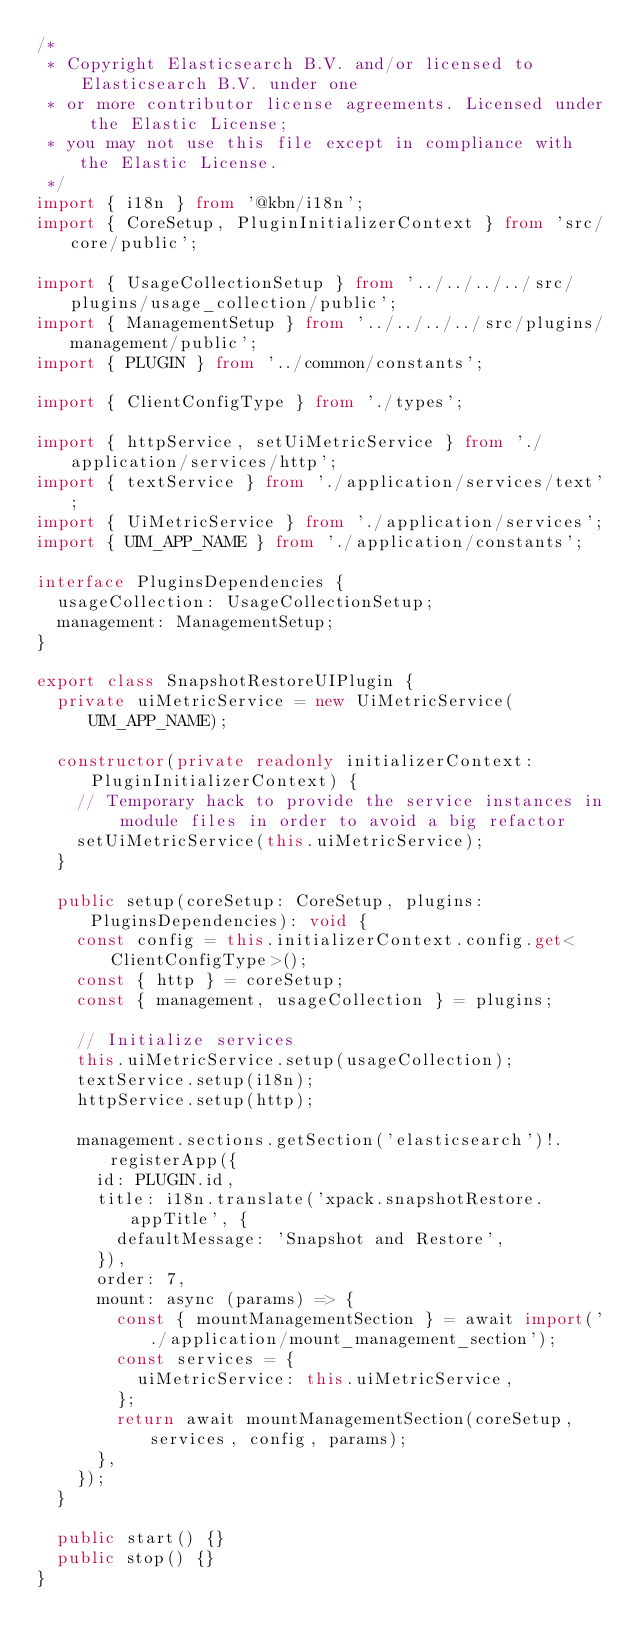Convert code to text. <code><loc_0><loc_0><loc_500><loc_500><_TypeScript_>/*
 * Copyright Elasticsearch B.V. and/or licensed to Elasticsearch B.V. under one
 * or more contributor license agreements. Licensed under the Elastic License;
 * you may not use this file except in compliance with the Elastic License.
 */
import { i18n } from '@kbn/i18n';
import { CoreSetup, PluginInitializerContext } from 'src/core/public';

import { UsageCollectionSetup } from '../../../../src/plugins/usage_collection/public';
import { ManagementSetup } from '../../../../src/plugins/management/public';
import { PLUGIN } from '../common/constants';

import { ClientConfigType } from './types';

import { httpService, setUiMetricService } from './application/services/http';
import { textService } from './application/services/text';
import { UiMetricService } from './application/services';
import { UIM_APP_NAME } from './application/constants';

interface PluginsDependencies {
  usageCollection: UsageCollectionSetup;
  management: ManagementSetup;
}

export class SnapshotRestoreUIPlugin {
  private uiMetricService = new UiMetricService(UIM_APP_NAME);

  constructor(private readonly initializerContext: PluginInitializerContext) {
    // Temporary hack to provide the service instances in module files in order to avoid a big refactor
    setUiMetricService(this.uiMetricService);
  }

  public setup(coreSetup: CoreSetup, plugins: PluginsDependencies): void {
    const config = this.initializerContext.config.get<ClientConfigType>();
    const { http } = coreSetup;
    const { management, usageCollection } = plugins;

    // Initialize services
    this.uiMetricService.setup(usageCollection);
    textService.setup(i18n);
    httpService.setup(http);

    management.sections.getSection('elasticsearch')!.registerApp({
      id: PLUGIN.id,
      title: i18n.translate('xpack.snapshotRestore.appTitle', {
        defaultMessage: 'Snapshot and Restore',
      }),
      order: 7,
      mount: async (params) => {
        const { mountManagementSection } = await import('./application/mount_management_section');
        const services = {
          uiMetricService: this.uiMetricService,
        };
        return await mountManagementSection(coreSetup, services, config, params);
      },
    });
  }

  public start() {}
  public stop() {}
}
</code> 